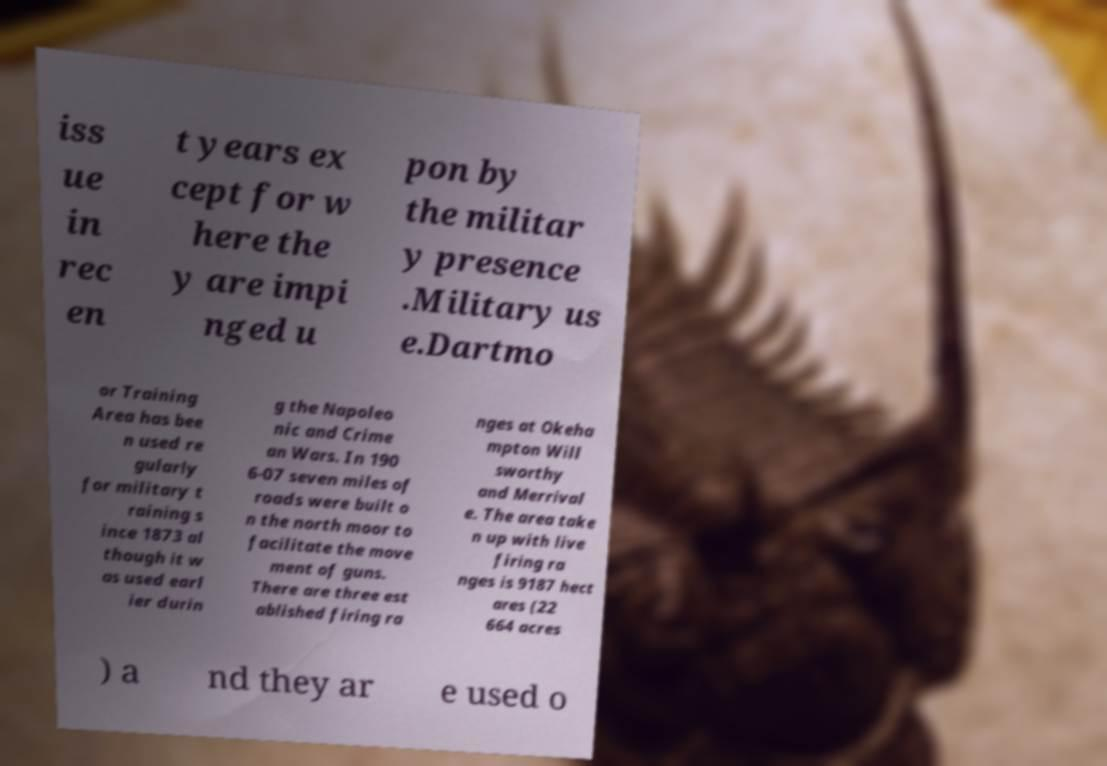Could you assist in decoding the text presented in this image and type it out clearly? iss ue in rec en t years ex cept for w here the y are impi nged u pon by the militar y presence .Military us e.Dartmo or Training Area has bee n used re gularly for military t raining s ince 1873 al though it w as used earl ier durin g the Napoleo nic and Crime an Wars. In 190 6-07 seven miles of roads were built o n the north moor to facilitate the move ment of guns. There are three est ablished firing ra nges at Okeha mpton Will sworthy and Merrival e. The area take n up with live firing ra nges is 9187 hect ares (22 664 acres ) a nd they ar e used o 